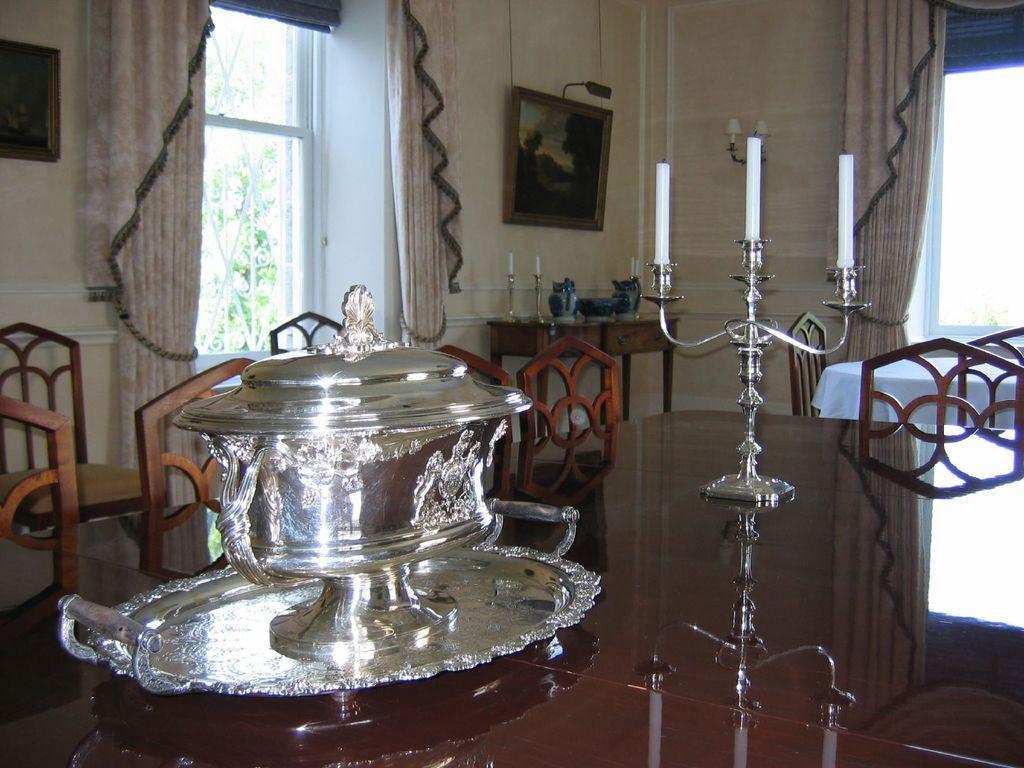Can you describe this image briefly? In this picture we can see a silver plate and a bowl kept on a dining table. We can also see chairs & candles and tables. 